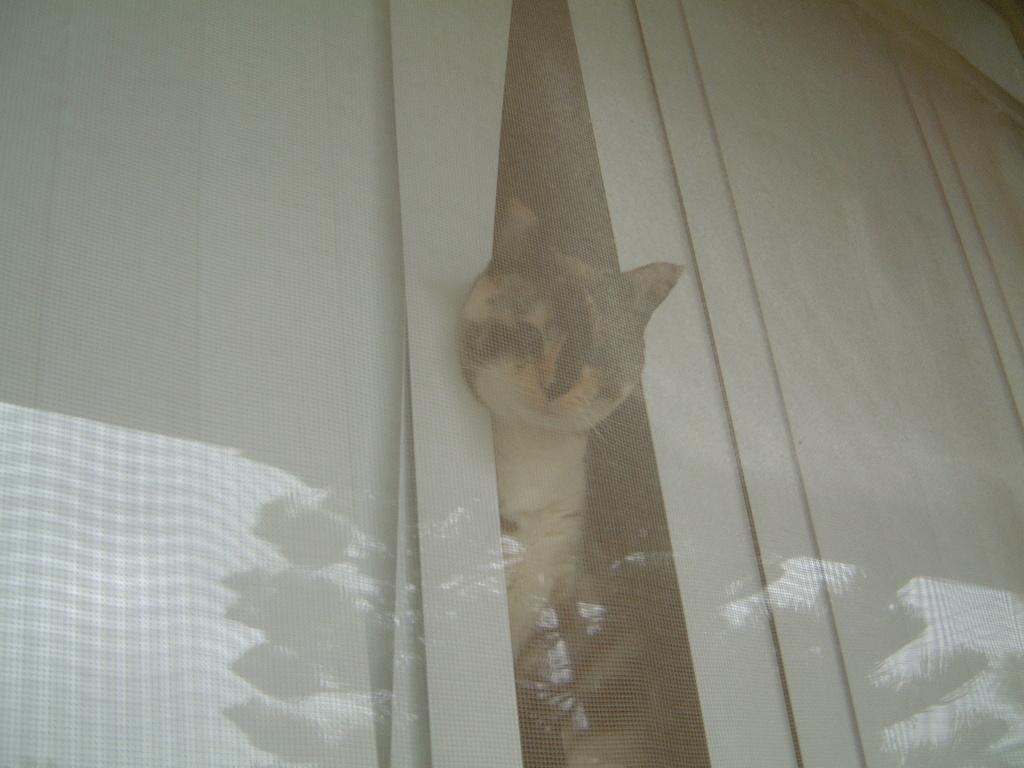Can you describe this image briefly? In this image, there is a cat in between curtains. 